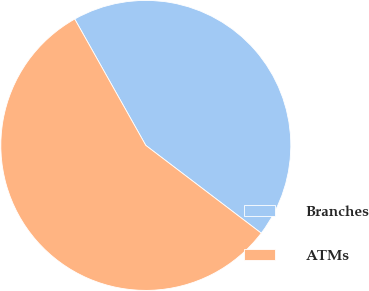Convert chart to OTSL. <chart><loc_0><loc_0><loc_500><loc_500><pie_chart><fcel>Branches<fcel>ATMs<nl><fcel>43.5%<fcel>56.5%<nl></chart> 